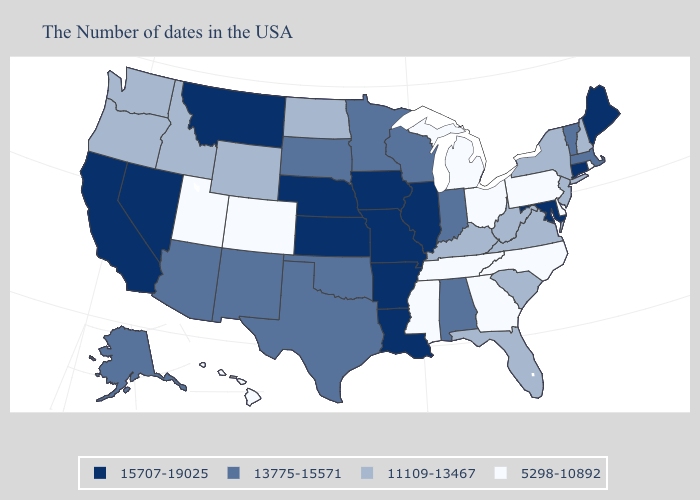What is the value of Massachusetts?
Be succinct. 13775-15571. What is the value of California?
Be succinct. 15707-19025. Name the states that have a value in the range 15707-19025?
Be succinct. Maine, Connecticut, Maryland, Illinois, Louisiana, Missouri, Arkansas, Iowa, Kansas, Nebraska, Montana, Nevada, California. Name the states that have a value in the range 11109-13467?
Concise answer only. New Hampshire, New York, New Jersey, Virginia, South Carolina, West Virginia, Florida, Kentucky, North Dakota, Wyoming, Idaho, Washington, Oregon. Among the states that border Iowa , which have the highest value?
Keep it brief. Illinois, Missouri, Nebraska. What is the value of Missouri?
Answer briefly. 15707-19025. Does Nevada have the highest value in the USA?
Answer briefly. Yes. What is the value of South Carolina?
Short answer required. 11109-13467. Name the states that have a value in the range 15707-19025?
Give a very brief answer. Maine, Connecticut, Maryland, Illinois, Louisiana, Missouri, Arkansas, Iowa, Kansas, Nebraska, Montana, Nevada, California. Name the states that have a value in the range 11109-13467?
Short answer required. New Hampshire, New York, New Jersey, Virginia, South Carolina, West Virginia, Florida, Kentucky, North Dakota, Wyoming, Idaho, Washington, Oregon. What is the highest value in states that border New Mexico?
Give a very brief answer. 13775-15571. Is the legend a continuous bar?
Write a very short answer. No. Does Rhode Island have the lowest value in the Northeast?
Write a very short answer. Yes. Does Kentucky have the lowest value in the South?
Write a very short answer. No. What is the value of Montana?
Concise answer only. 15707-19025. 